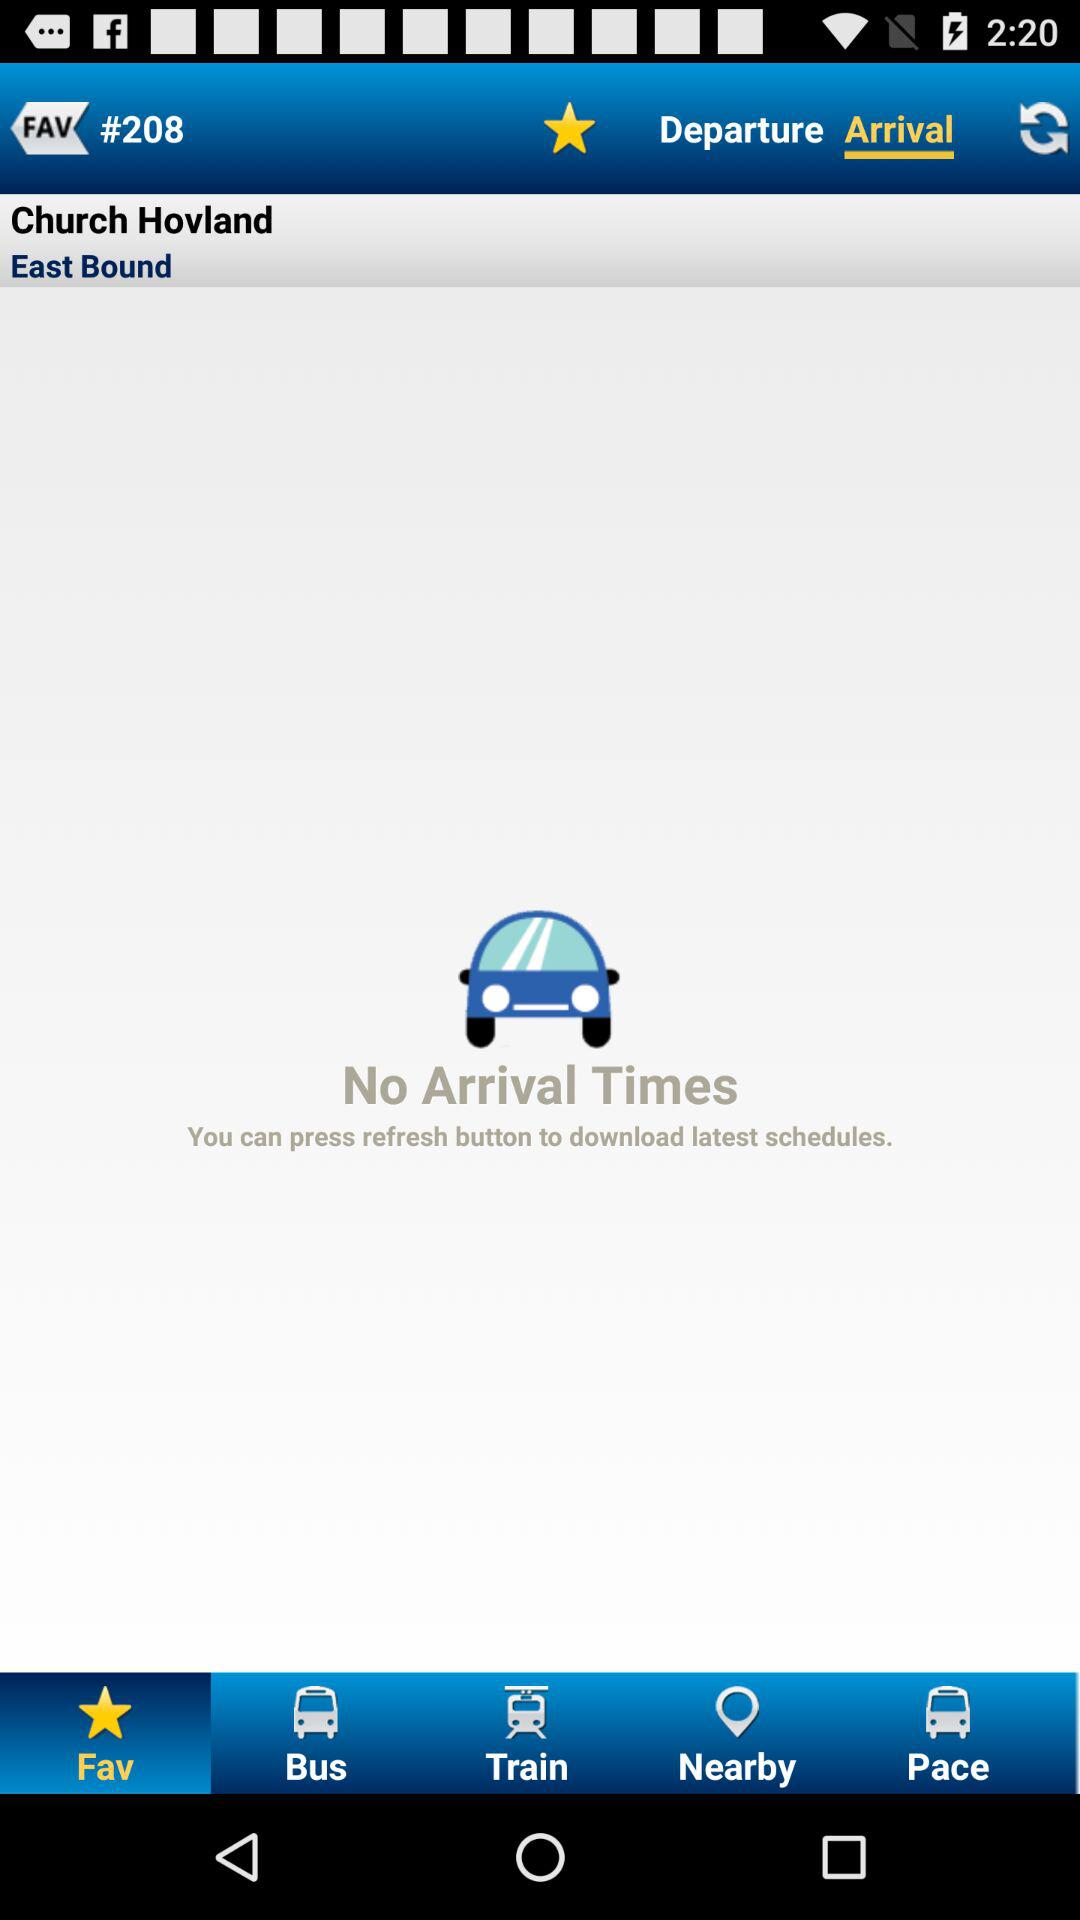What location is mentioned? The mentioned location is Church Hovland. 